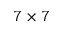Convert formula to latex. <formula><loc_0><loc_0><loc_500><loc_500>7 \times 7</formula> 